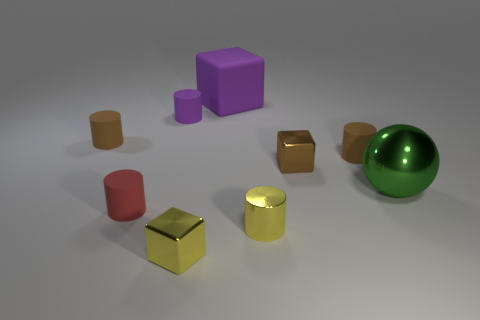Subtract all purple matte cylinders. How many cylinders are left? 4 Subtract all purple cylinders. How many cylinders are left? 4 Subtract all cyan cylinders. Subtract all purple spheres. How many cylinders are left? 5 Subtract all balls. How many objects are left? 8 Add 2 big blue metallic cylinders. How many big blue metallic cylinders exist? 2 Subtract 0 red cubes. How many objects are left? 9 Subtract all shiny cubes. Subtract all small purple rubber cylinders. How many objects are left? 6 Add 6 tiny brown things. How many tiny brown things are left? 9 